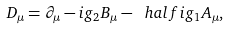<formula> <loc_0><loc_0><loc_500><loc_500>D _ { \mu } = \partial _ { \mu } - i g _ { 2 } B _ { \mu } - \ h a l f i g _ { 1 } A _ { \mu } ,</formula> 